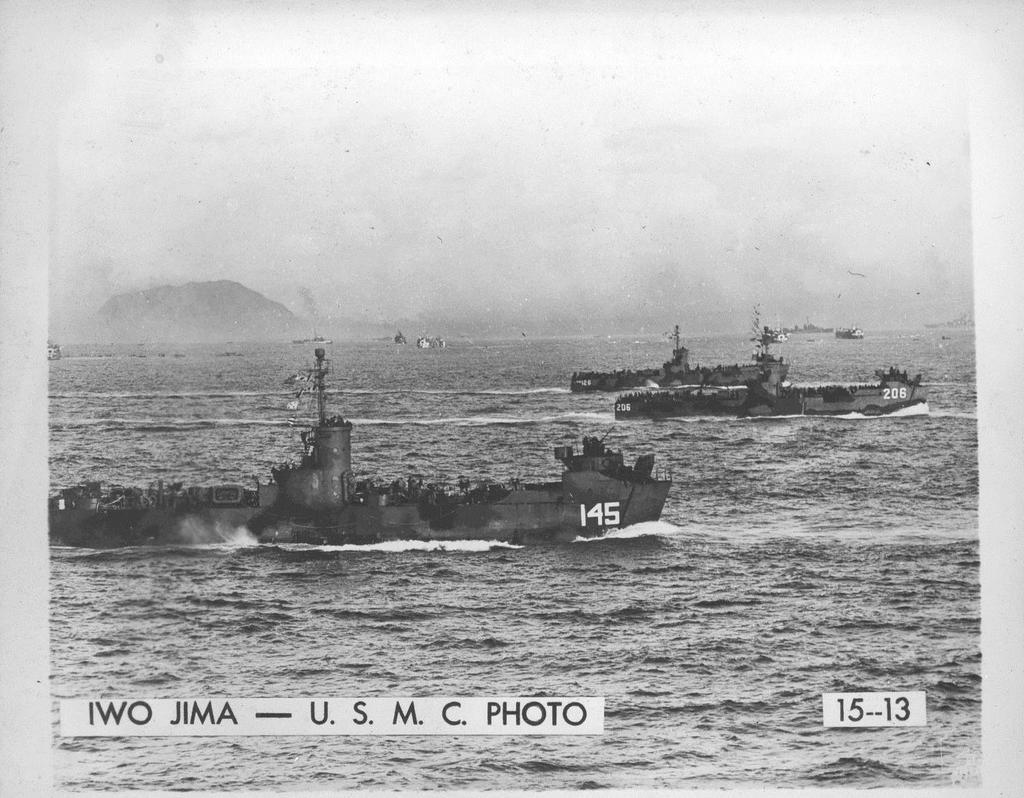<image>
Give a short and clear explanation of the subsequent image. A black and white photo shows old battle ships from the United States Marine Core on the water. 